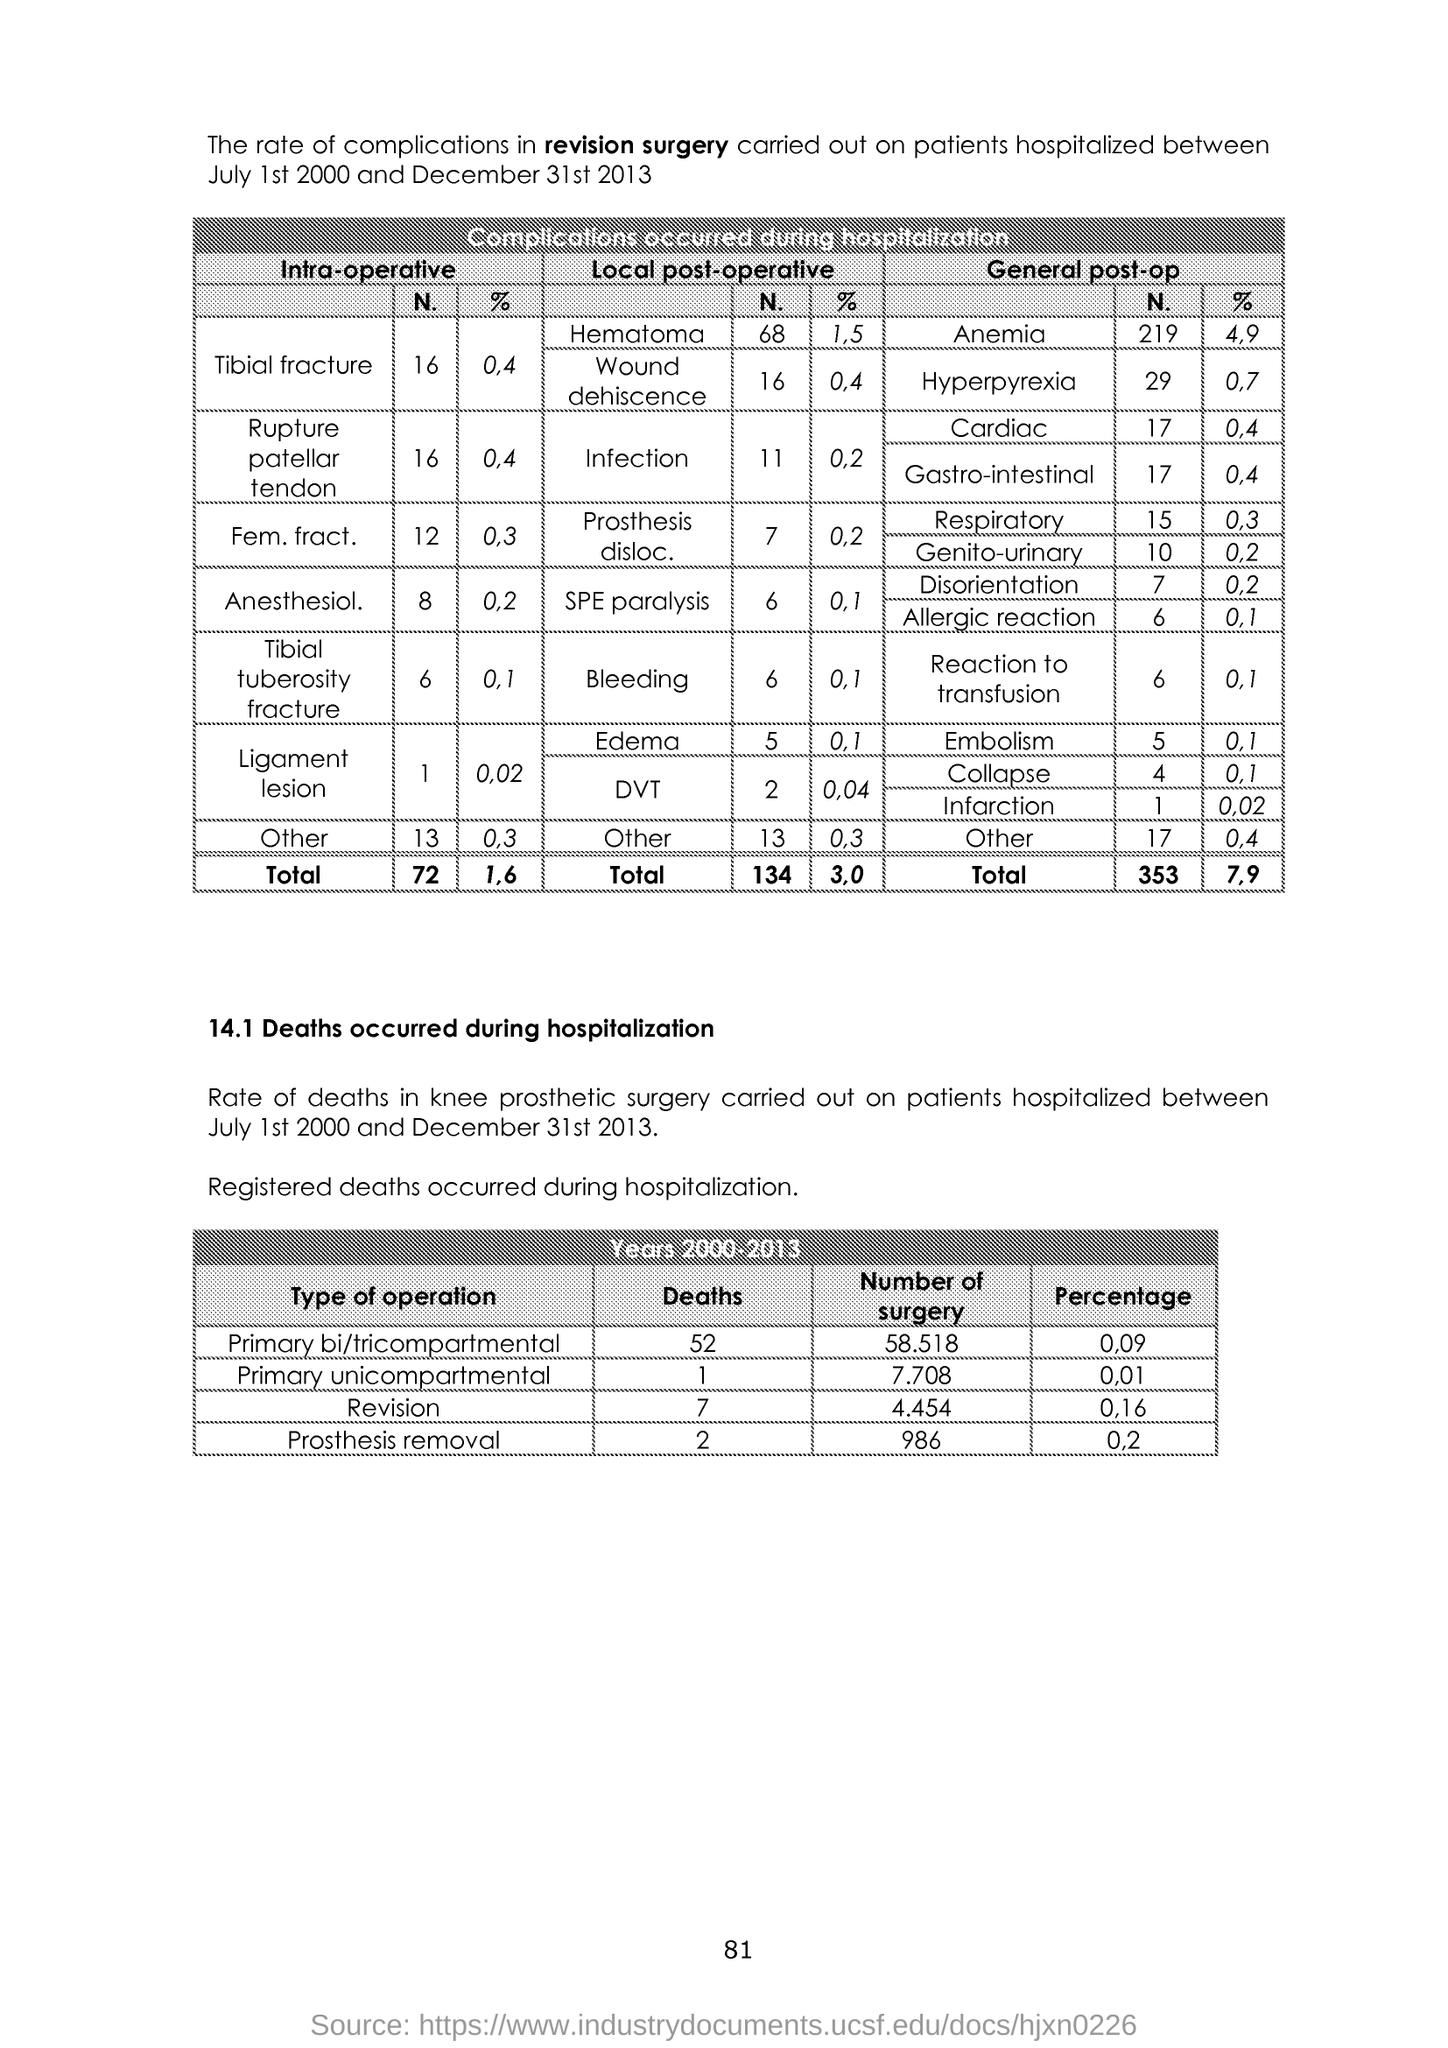List a handful of essential elements in this visual. The title mentioned in section 14.1 is "Deaths occurred during hospitalization. 